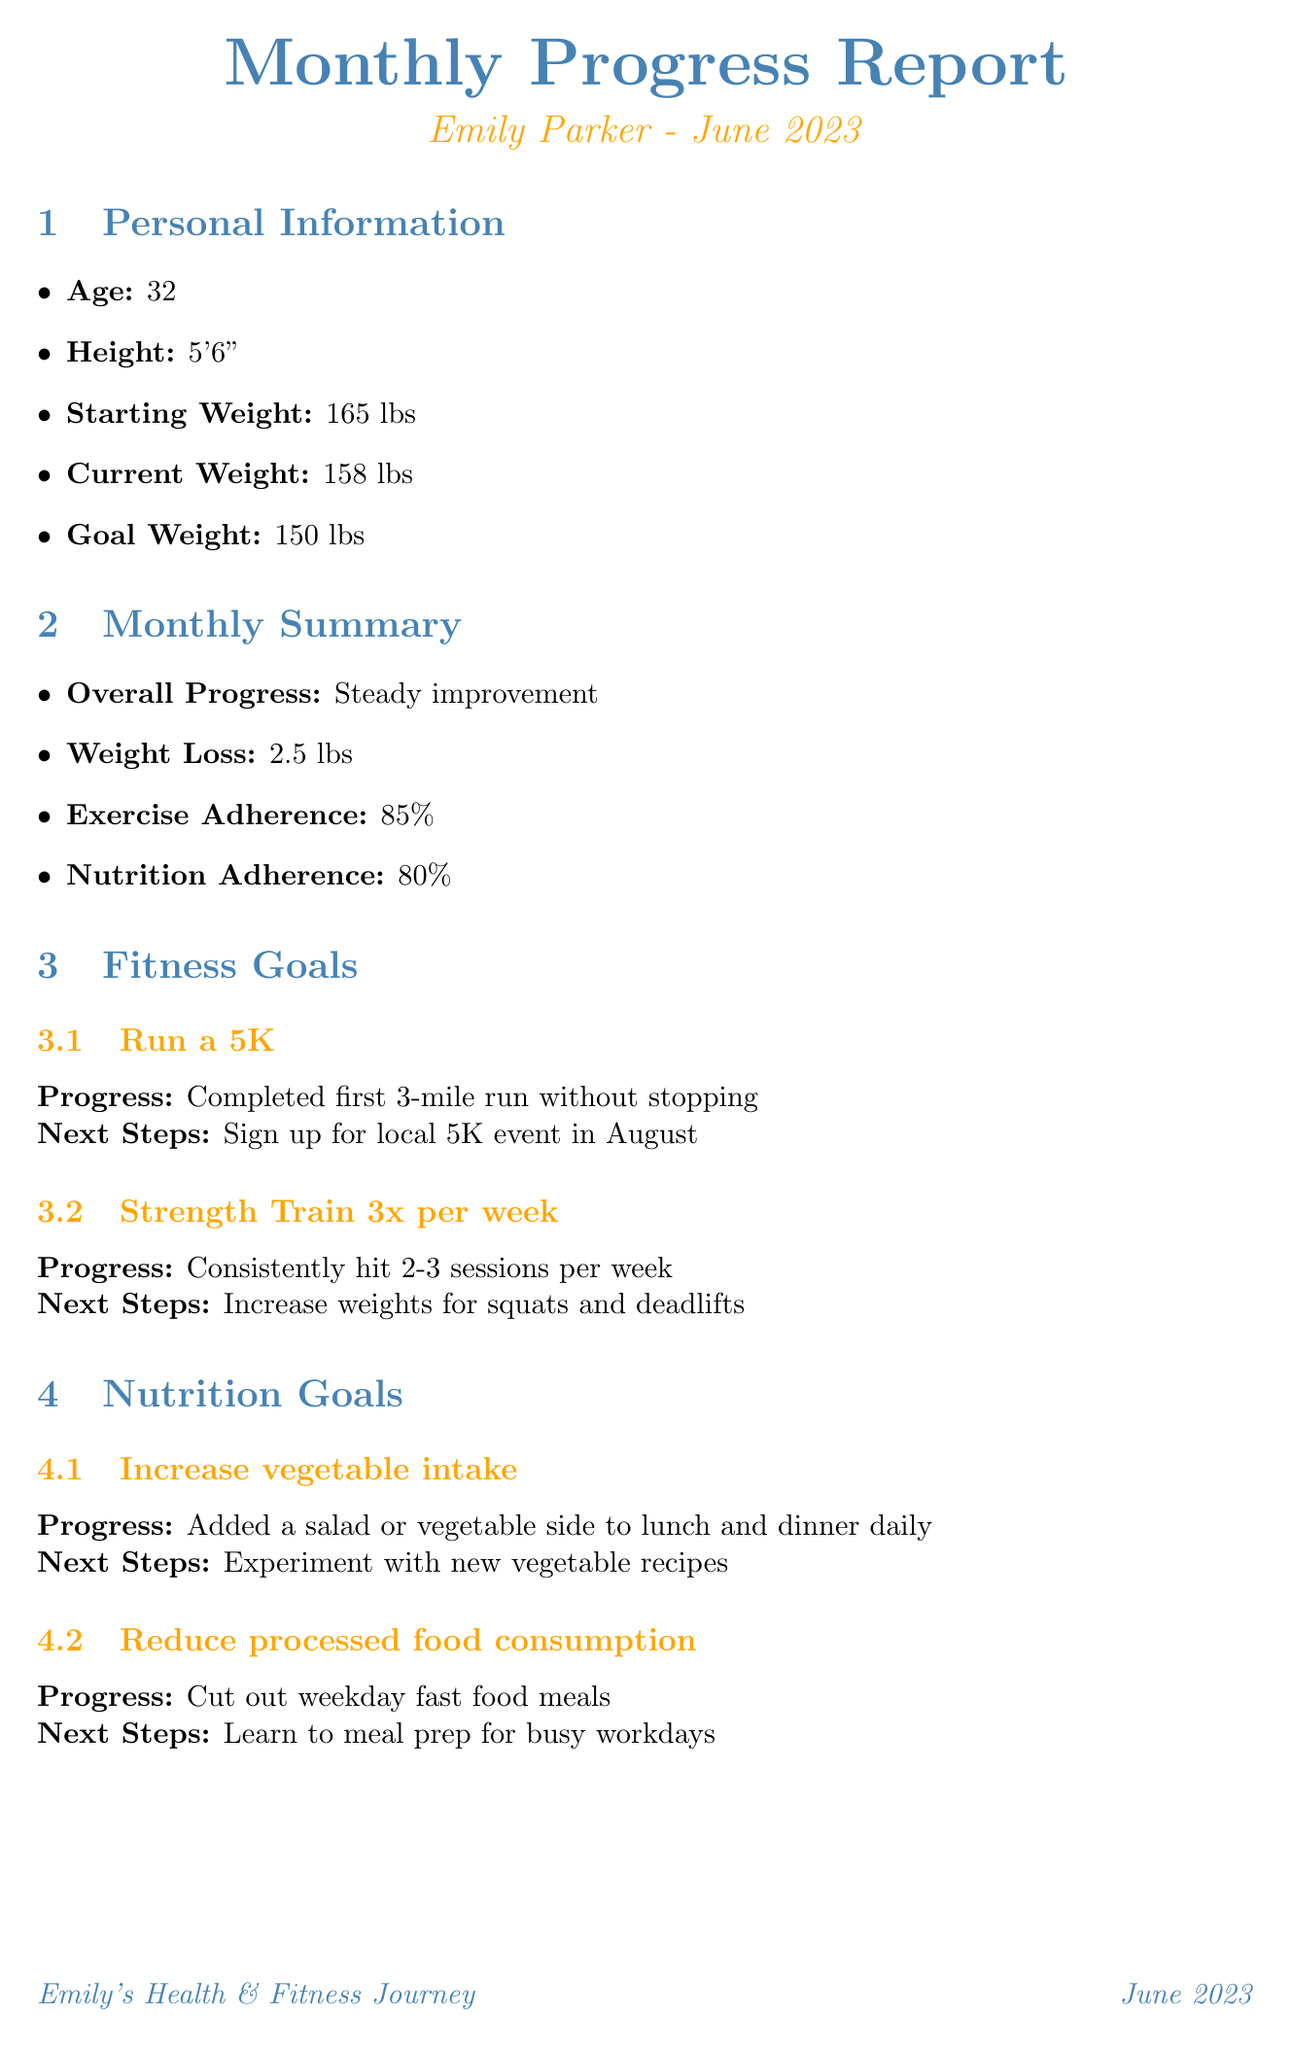What is Emily's starting weight? The document provides personal information, including the starting weight, which is 165 lbs.
Answer: 165 lbs What is Emily's current weight? The current weight is part of the personal information section, listed as 158 lbs.
Answer: 158 lbs What was the overall progress in June 2023? The overall progress is summarized in the monthly summary section as "Steady improvement."
Answer: Steady improvement How many desserts does Emily consume weekly on average? The dessert consumption section indicates that her weekly average of dessert consumption is 3.
Answer: 3 What fitness goal has Emily completed? The fitness goals section shows that she has completed her first 3-mile run without stopping under the goal to run a 5K.
Answer: 3-mile run What are the healthier dessert alternatives Emily has tried? The document lists alternatives like Greek yogurt with honey and berries, banana 'nice cream', and chia seed pudding.
Answer: Greek yogurt with honey and berries, banana 'nice cream', chia seed pudding What impact has dessert consumption had on Emily's mood? The document mentions that dessert consumption has led to an improved mood and satisfaction, which reduces the likelihood of binge eating.
Answer: Improved mood and satisfaction What specific challenge did Emily face related to dessert? One of the challenges mentioned in the document is balancing dessert intake during summer barbecues.
Answer: Balancing dessert intake during summer barbecues What are the next steps for Emily regarding sugar-free desserts? The next month focus section outlines that she plans to experiment with sugar-free dessert recipes.
Answer: Experiment with sugar-free dessert recipes 